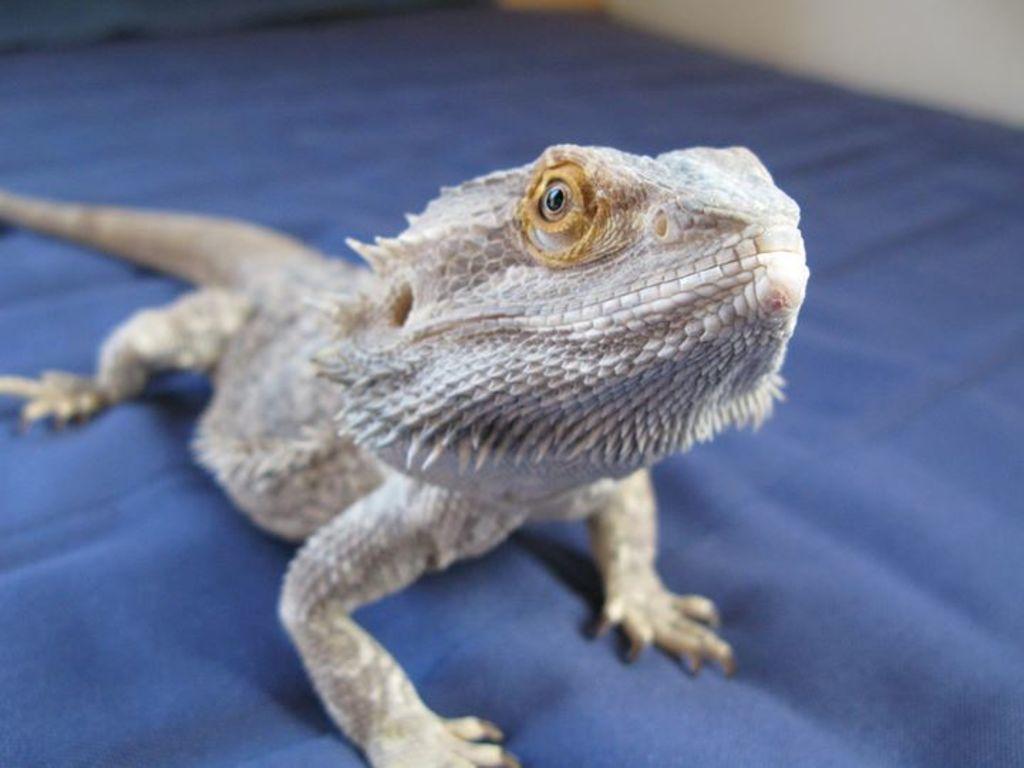Describe this image in one or two sentences. In this image there is chameleon on the carpet. 